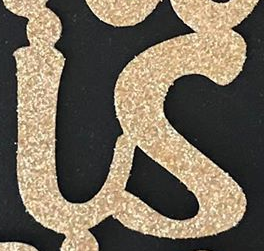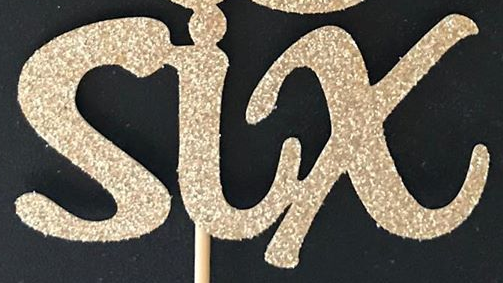What text appears in these images from left to right, separated by a semicolon? is; six 